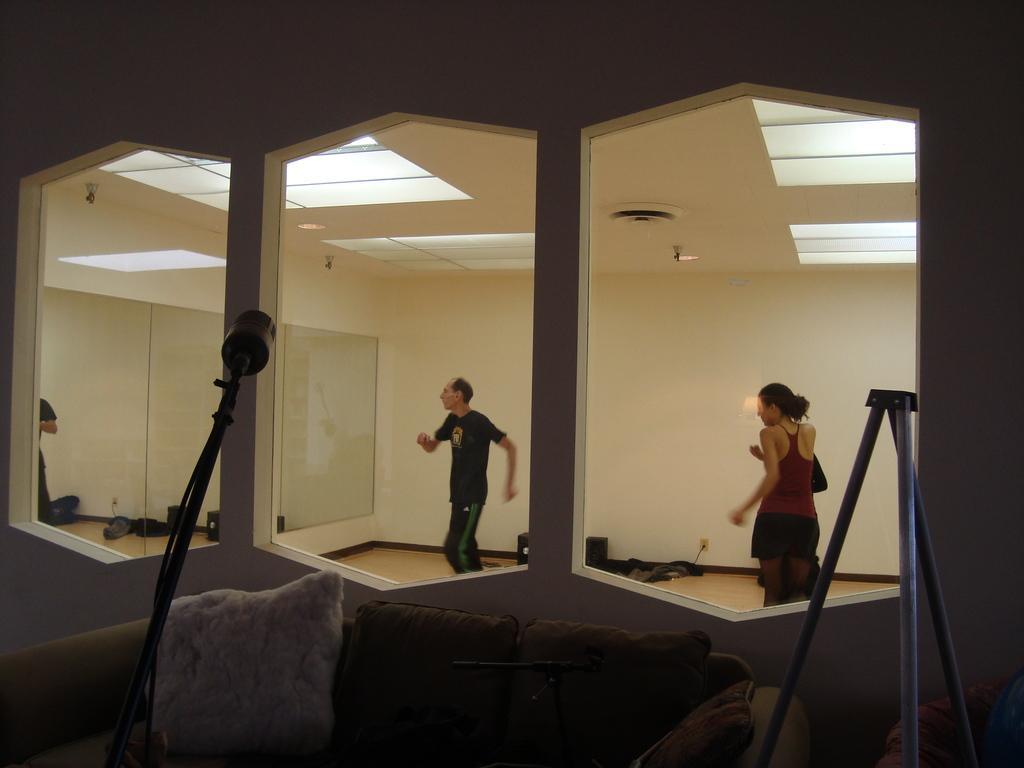In one or two sentences, can you explain what this image depicts? In this image we can see persons standing on the ground. In the background we can see electric lights, walls and mirrors. In the foreground we can see sofa set, tripods and pillows. 